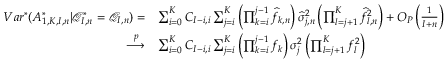<formula> <loc_0><loc_0><loc_500><loc_500>\begin{array} { r l } { V a r ^ { * } ( A _ { 1 , K , I , n } ^ { * } | \mathcal { Q } _ { I , n } ^ { * } = \mathcal { Q } _ { I , n } ) = } & { \sum _ { i = 0 } ^ { K } C _ { I - i , i } \sum _ { j = i } ^ { K } \left ( \prod _ { k = i } ^ { j - 1 } \widehat { f } _ { k , n } \right ) \widehat { \sigma } _ { j , n } ^ { 2 } \left ( \prod _ { l = j + 1 } ^ { K } \widehat { f } _ { l , n } ^ { 2 } \right ) + O _ { P } \left ( \frac { 1 } { I + n } \right ) } \\ { \overset { p } { \longrightarrow } } & { \sum _ { i = 0 } ^ { K } C _ { I - i , i } \sum _ { j = i } ^ { K } \left ( \prod _ { k = i } ^ { j - 1 } f _ { k } \right ) \sigma _ { j } ^ { 2 } \left ( \prod _ { l = j + 1 } ^ { K } f _ { l } ^ { 2 } \right ) } \end{array}</formula> 